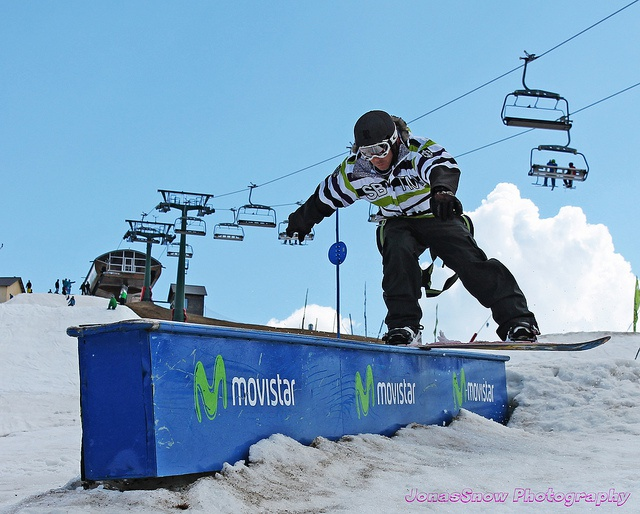Describe the objects in this image and their specific colors. I can see people in lightblue, black, gray, and darkgray tones, snowboard in lightblue, black, gray, darkgray, and navy tones, people in lightblue, navy, black, and gray tones, people in lightblue, black, and gray tones, and people in lightblue, black, gray, and blue tones in this image. 